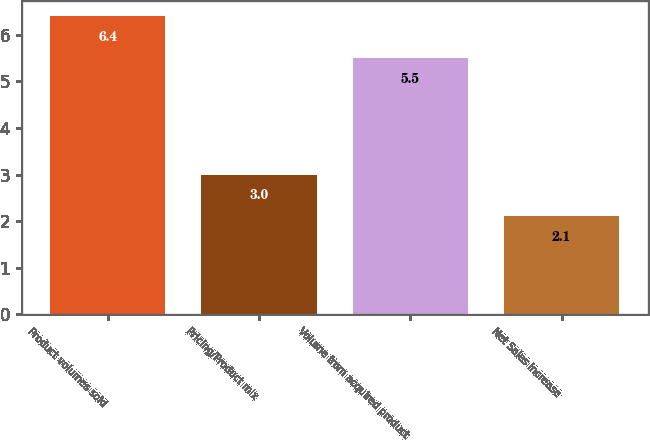Convert chart to OTSL. <chart><loc_0><loc_0><loc_500><loc_500><bar_chart><fcel>Product volumes sold<fcel>Pricing/Product mix<fcel>Volume from acquired product<fcel>Net Sales increase<nl><fcel>6.4<fcel>3<fcel>5.5<fcel>2.1<nl></chart> 